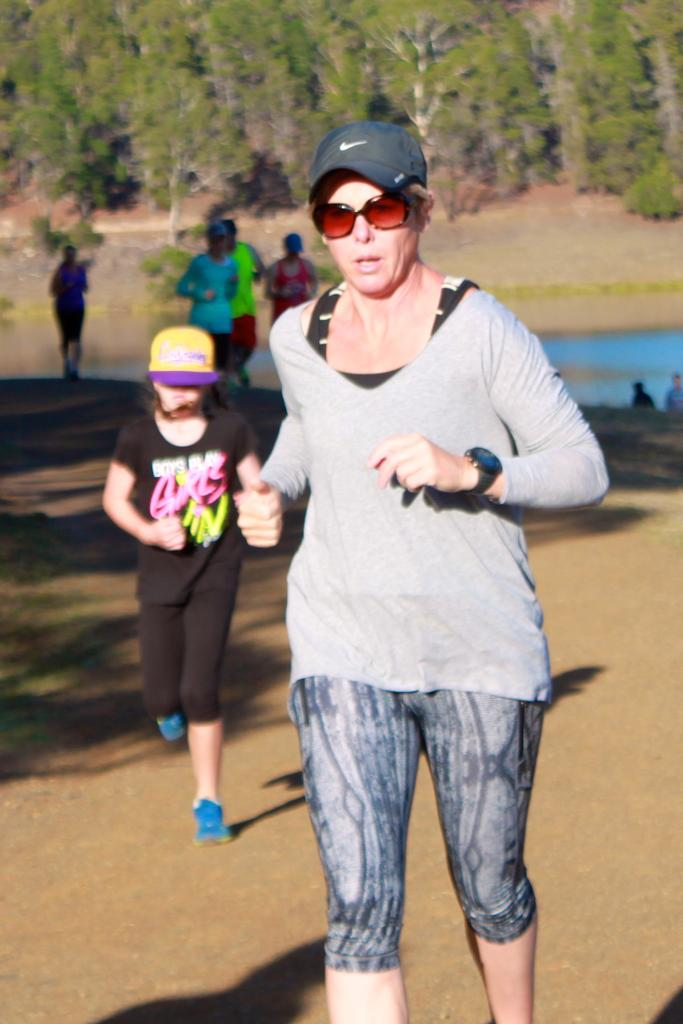Who is the main subject in the foreground of the image? There is a woman in the foreground of the image. What is the woman doing in the image? The woman appears to be jogging. Can you describe the people behind the woman? There are other people behind the woman. What can be seen in the background of the image? There are trees in the background of the image. What is the plot of the story unfolding in the image? There is no story or plot depicted in the image; it simply shows a woman jogging with other people behind her and trees in the background. 